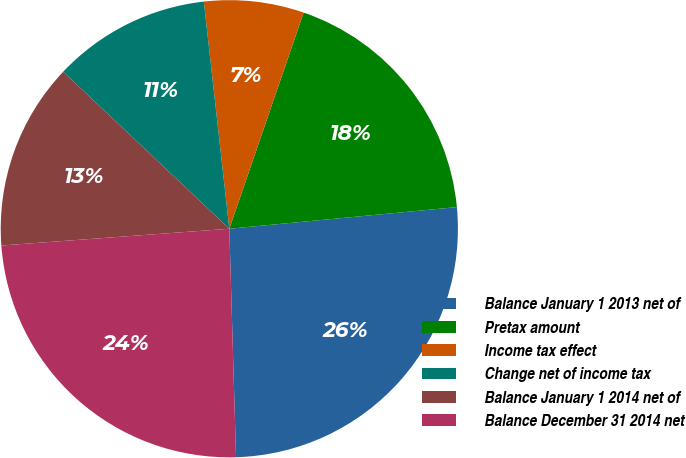Convert chart. <chart><loc_0><loc_0><loc_500><loc_500><pie_chart><fcel>Balance January 1 2013 net of<fcel>Pretax amount<fcel>Income tax effect<fcel>Change net of income tax<fcel>Balance January 1 2014 net of<fcel>Balance December 31 2014 net<nl><fcel>26.04%<fcel>18.22%<fcel>7.05%<fcel>11.17%<fcel>13.22%<fcel>24.3%<nl></chart> 